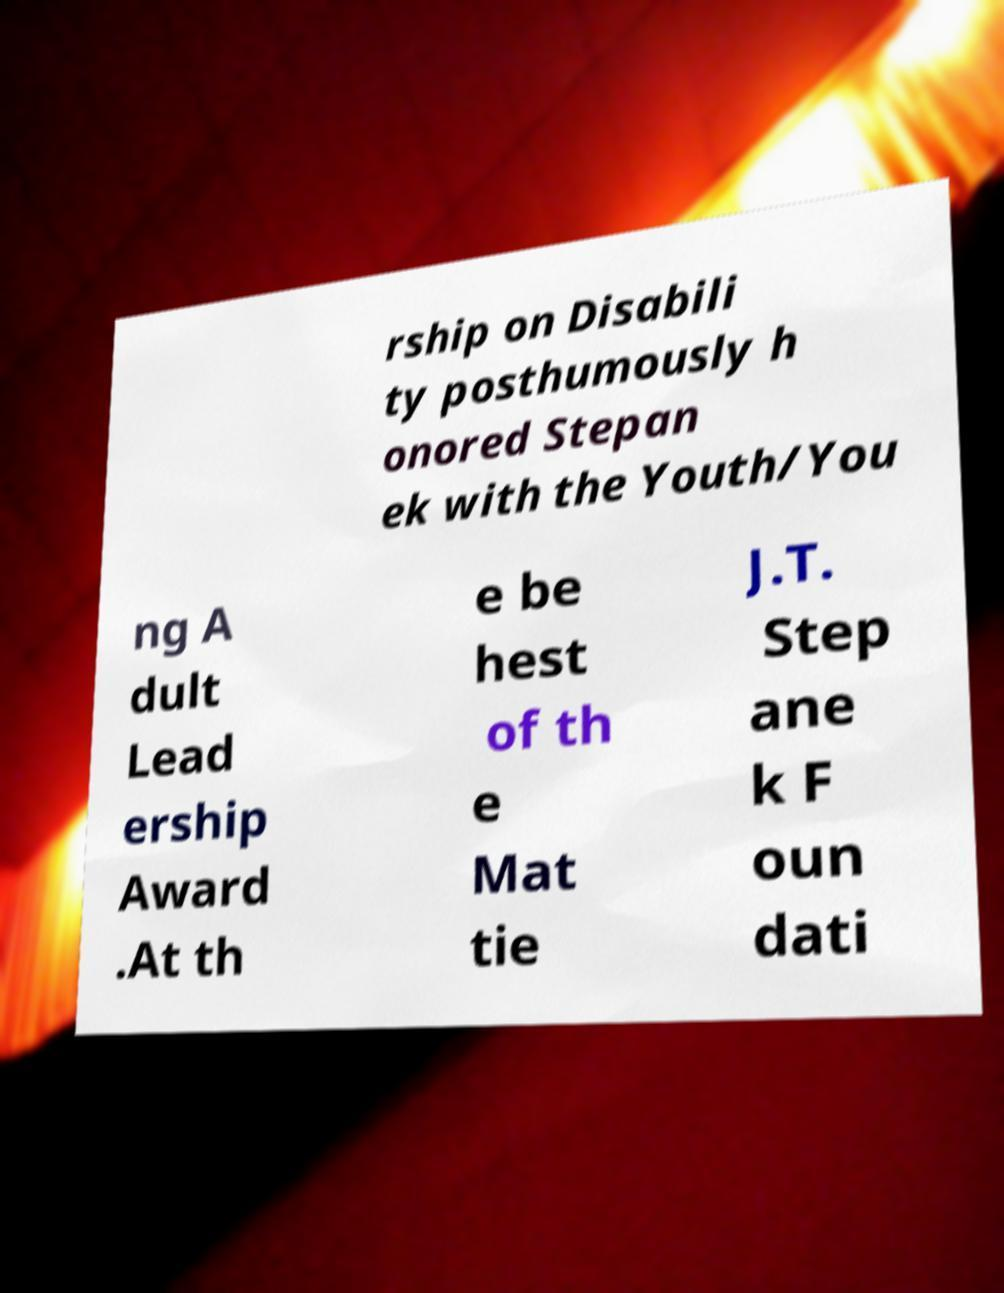Could you extract and type out the text from this image? rship on Disabili ty posthumously h onored Stepan ek with the Youth/You ng A dult Lead ership Award .At th e be hest of th e Mat tie J.T. Step ane k F oun dati 